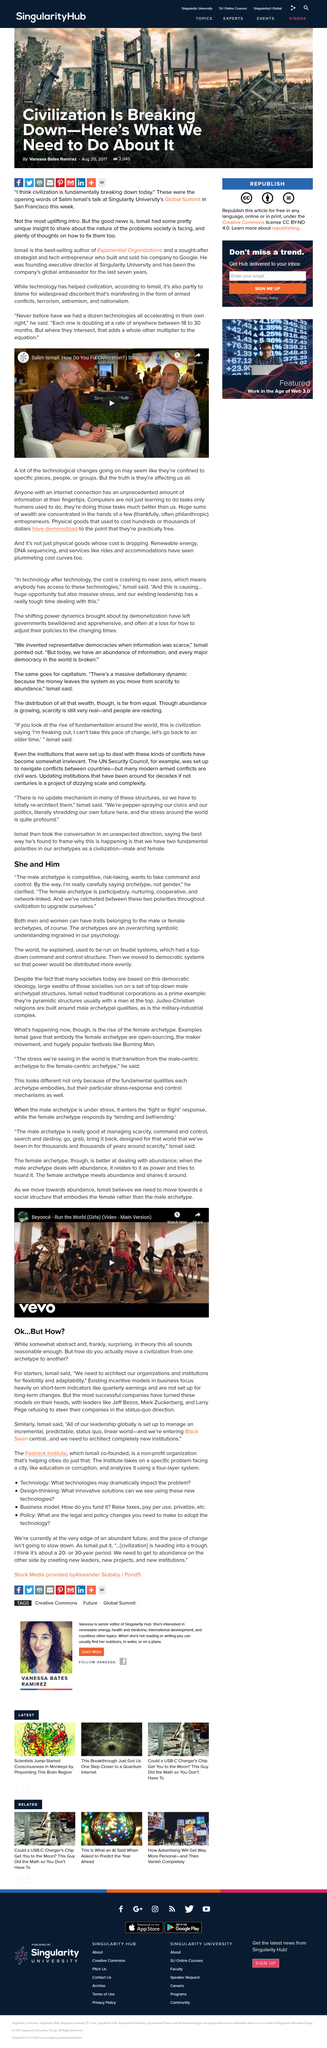Point out several critical features in this image. The male archetype is competitive, and it is considered the competitive archetype. Existing incentive models in business primarily focus on short-term indicators rather than long-term sustainability and stakeholder interests. Yes, there is a significant concentration of wealth among a small number of entrepreneurs. The title of the video is "Salim Ismail: How do you fix civilization? Singularity Hub" and it is shareable. Yes, men can have nurturing traits that are typically associated with women. 